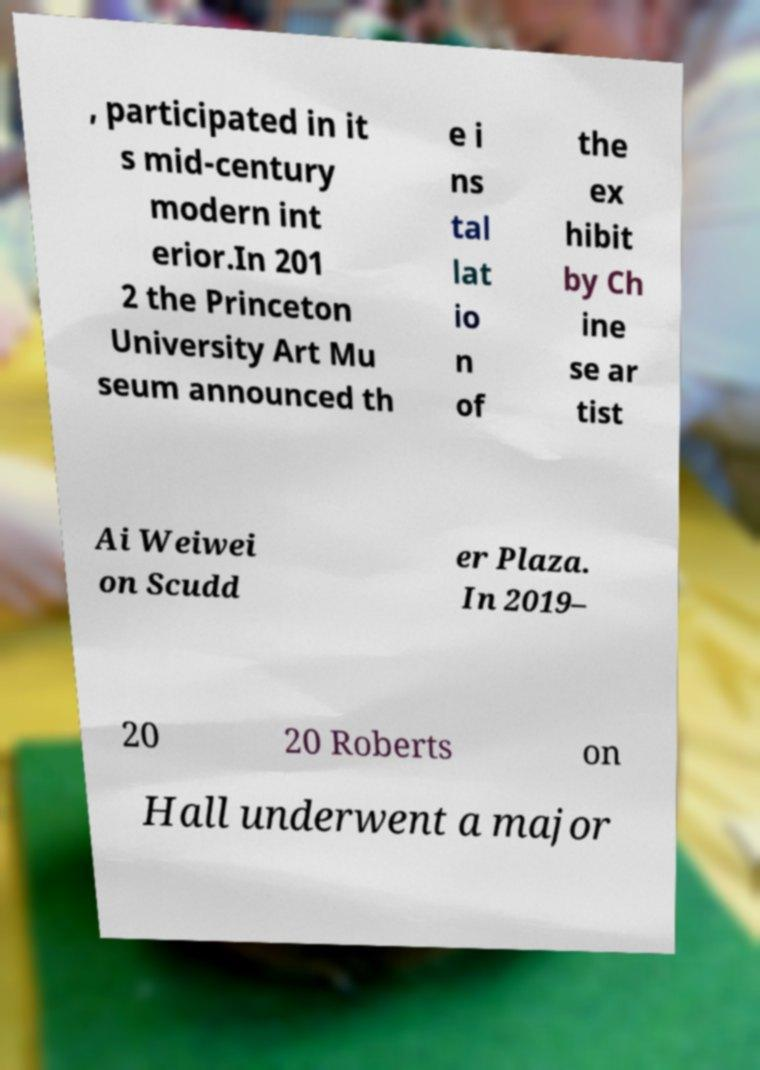What messages or text are displayed in this image? I need them in a readable, typed format. , participated in it s mid-century modern int erior.In 201 2 the Princeton University Art Mu seum announced th e i ns tal lat io n of the ex hibit by Ch ine se ar tist Ai Weiwei on Scudd er Plaza. In 2019– 20 20 Roberts on Hall underwent a major 